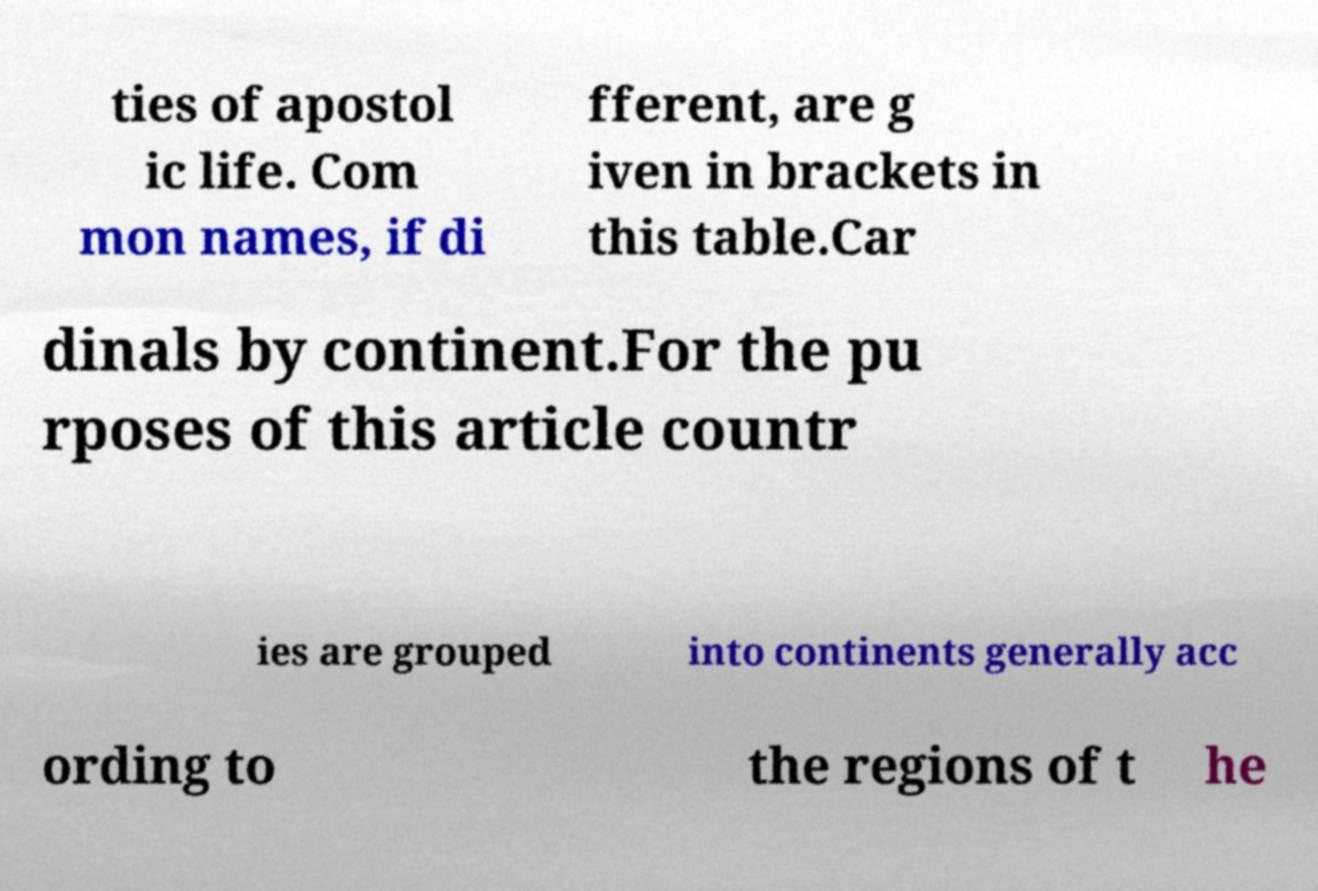There's text embedded in this image that I need extracted. Can you transcribe it verbatim? ties of apostol ic life. Com mon names, if di fferent, are g iven in brackets in this table.Car dinals by continent.For the pu rposes of this article countr ies are grouped into continents generally acc ording to the regions of t he 